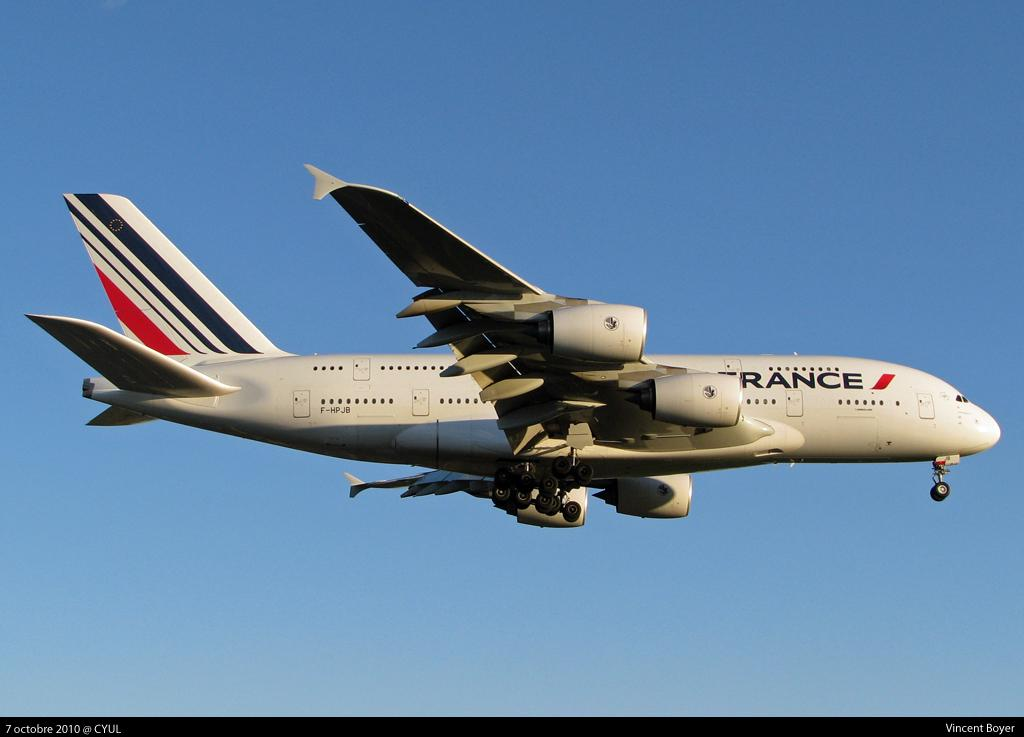<image>
Present a compact description of the photo's key features. A France Air commercial jet is flying in a clear blue sky. 